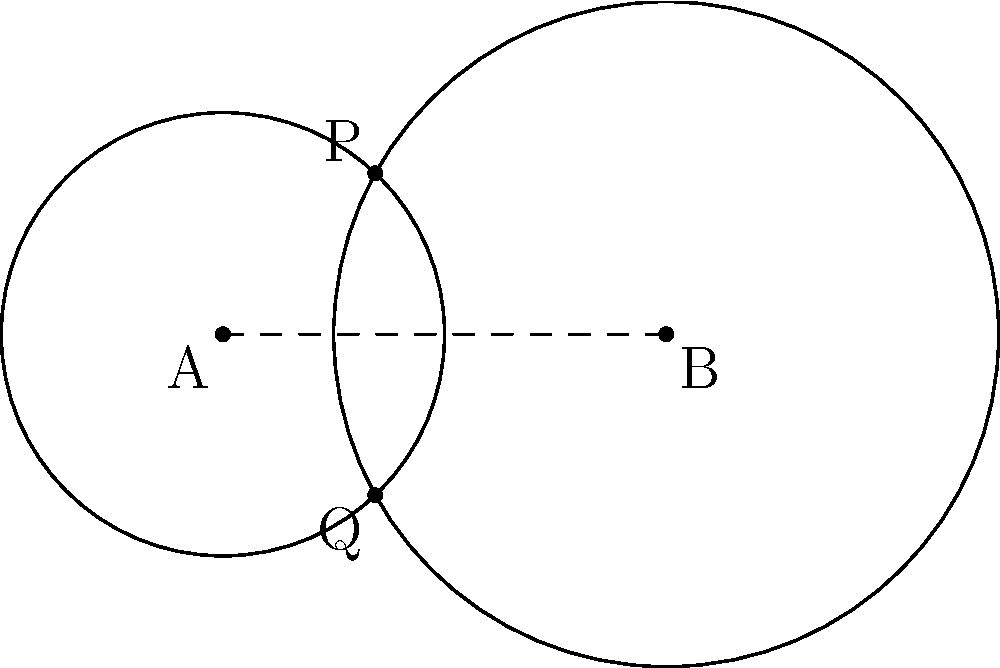In der Abbildung sehen Sie zwei sich schneidende Kreise. Kreis A hat den Radius 2 und Kreis B den Radius 3. Der Abstand zwischen den Mittelpunkten A und B beträgt 4 Einheiten. Wie viele Schnittpunkte haben diese beiden Kreise? Begründen Sie Ihre Antwort mit einem Bezug zu Johannes W. Betz' Werk "Geometrie". Um diese Frage zu beantworten, folgen wir einem Ansatz, der an Johannes W. Betz' Methodik in "Geometrie" erinnert:

1. Zunächst betrachten wir die Bedingungen für Schnittpunkte zweier Kreise:
   - Die Summe der Radien muss größer sein als der Abstand der Mittelpunkte.
   - Der Abstand der Mittelpunkte muss größer sein als die Differenz der Radien.

2. In unserem Fall:
   - Summe der Radien: $2 + 3 = 5$
   - Abstand der Mittelpunkte: $4$
   - Differenz der Radien: $|3 - 2| = 1$

3. Wir überprüfen die Bedingungen:
   - $5 > 4$: Die erste Bedingung ist erfüllt.
   - $4 > 1$: Die zweite Bedingung ist ebenfalls erfüllt.

4. Da beide Bedingungen erfüllt sind, schneiden sich die Kreise in genau zwei Punkten.

5. Mathematisch können wir dies auch mit der Formel für die Anzahl der Schnittpunkte $n$ bestätigen:
   $$n = 2 \text{ wenn } (r_1 - r_2)^2 < d^2 < (r_1 + r_2)^2$$
   wobei $r_1$ und $r_2$ die Radien und $d$ der Abstand der Mittelpunkte sind.

6. Einsetzen in die Formel:
   $$(2 - 3)^2 < 4^2 < (2 + 3)^2$$
   $$1 < 16 < 25$$

Diese Ungleichung ist wahr, was bestätigt, dass es zwei Schnittpunkte gibt.
Answer: 2 Schnittpunkte 